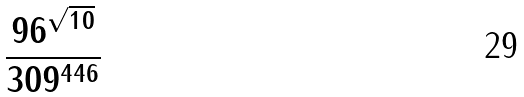Convert formula to latex. <formula><loc_0><loc_0><loc_500><loc_500>\frac { 9 6 ^ { \sqrt { 1 0 } } } { 3 0 9 ^ { 4 4 6 } }</formula> 